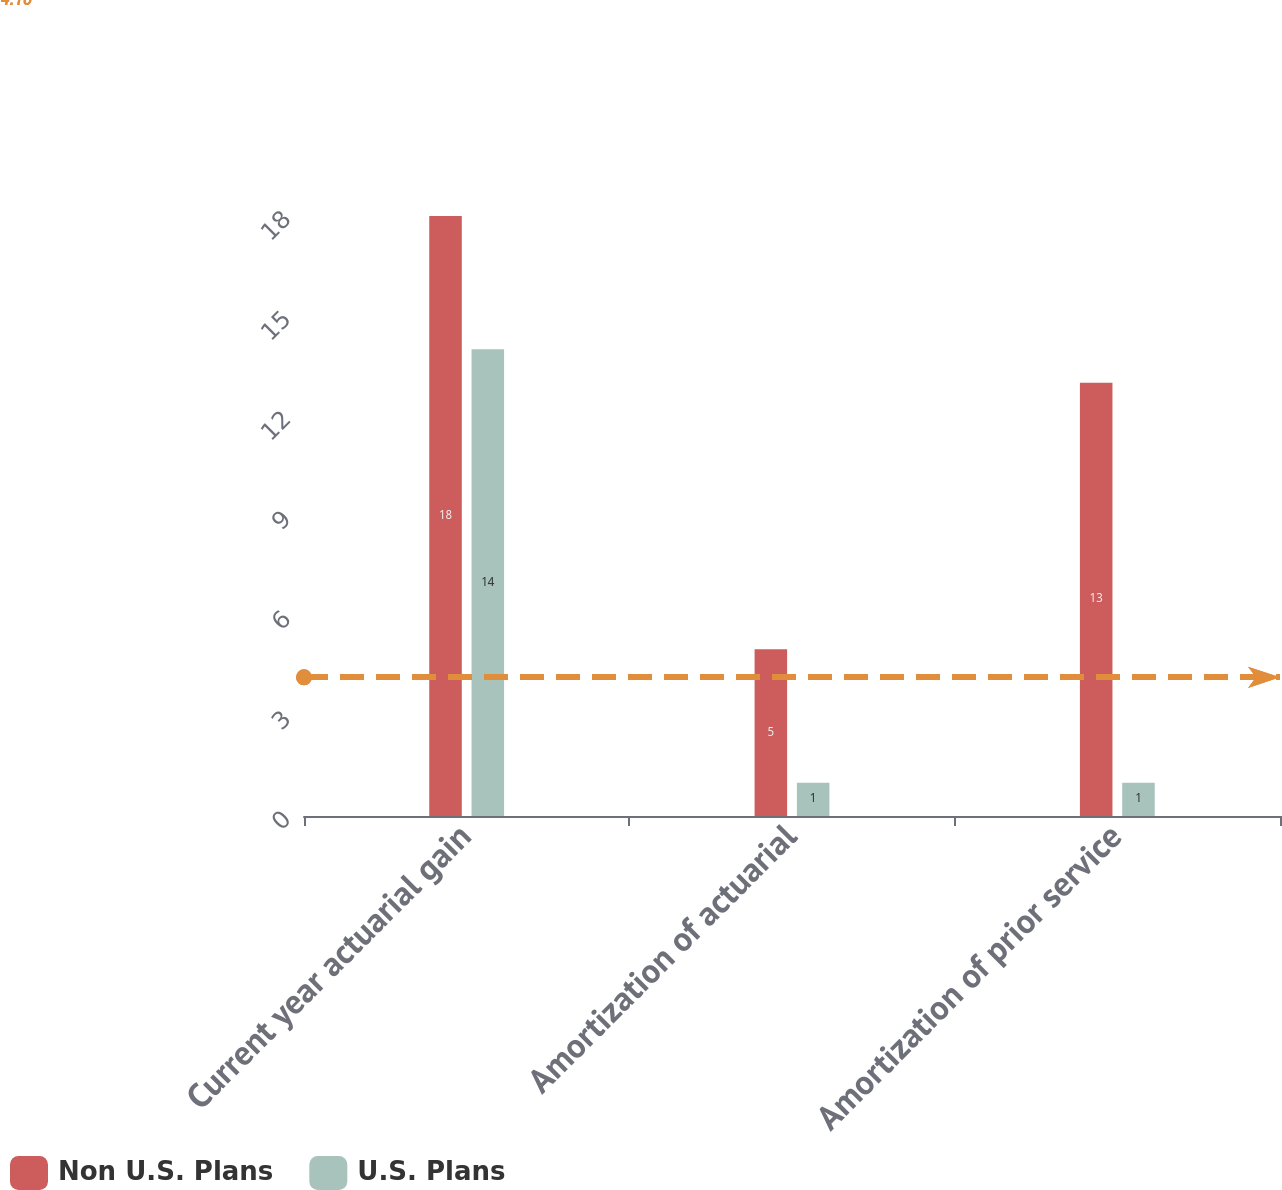<chart> <loc_0><loc_0><loc_500><loc_500><stacked_bar_chart><ecel><fcel>Current year actuarial gain<fcel>Amortization of actuarial<fcel>Amortization of prior service<nl><fcel>Non U.S. Plans<fcel>18<fcel>5<fcel>13<nl><fcel>U.S. Plans<fcel>14<fcel>1<fcel>1<nl></chart> 